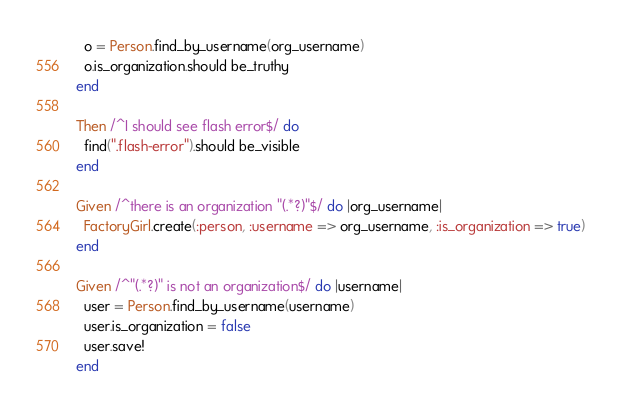Convert code to text. <code><loc_0><loc_0><loc_500><loc_500><_Ruby_>  o = Person.find_by_username(org_username)
  o.is_organization.should be_truthy
end

Then /^I should see flash error$/ do
  find(".flash-error").should be_visible
end

Given /^there is an organization "(.*?)"$/ do |org_username|
  FactoryGirl.create(:person, :username => org_username, :is_organization => true)
end

Given /^"(.*?)" is not an organization$/ do |username|
  user = Person.find_by_username(username)
  user.is_organization = false
  user.save!
end
</code> 